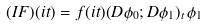<formula> <loc_0><loc_0><loc_500><loc_500>( I F ) ( i t ) = f ( i t ) ( D \phi _ { 0 } ; D \phi _ { 1 } ) _ { t } \, \phi _ { 1 }</formula> 